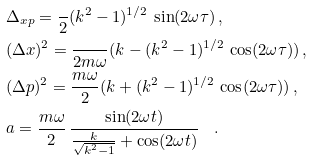<formula> <loc_0><loc_0><loc_500><loc_500>& \Delta _ { x p } = \frac { } { 2 } ( k ^ { 2 } - 1 ) ^ { 1 / 2 } \, \sin ( 2 \omega \tau ) \, , \\ & ( \Delta x ) ^ { 2 } = \frac { } { 2 m \omega } ( k - ( k ^ { 2 } - 1 ) ^ { 1 / 2 } \, \cos ( 2 \omega \tau ) ) \, , \\ & ( \Delta p ) ^ { 2 } = \frac { m \omega } { 2 } ( k + ( k ^ { 2 } - 1 ) ^ { 1 / 2 } \, \cos ( 2 \omega \tau ) ) \, , \\ & a = \frac { m \omega } { 2 } \, \frac { \sin ( 2 \omega t ) } { \frac { k } { \sqrt { k ^ { 2 } - 1 } } + \cos ( 2 \omega t ) } \quad .</formula> 